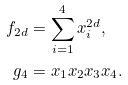<formula> <loc_0><loc_0><loc_500><loc_500>f _ { 2 d } & = \sum _ { i = 1 } ^ { 4 } x _ { i } ^ { 2 d } , \\ g _ { 4 } & = x _ { 1 } x _ { 2 } x _ { 3 } x _ { 4 } .</formula> 